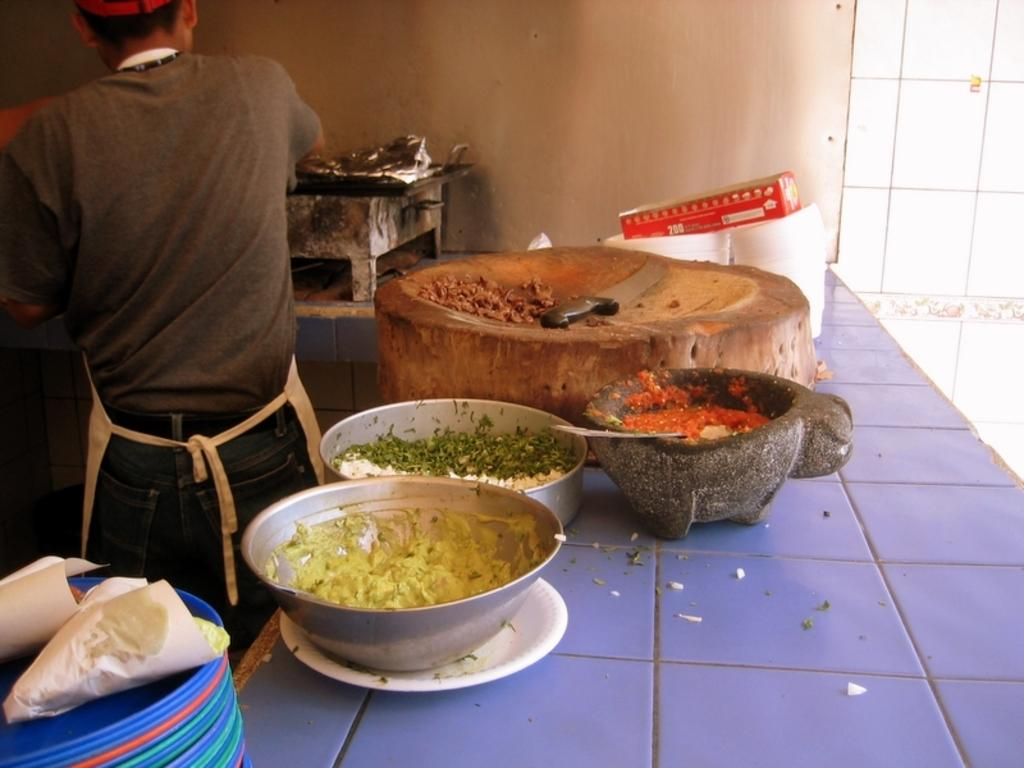What objects are present in the image that are typically used for serving or eating food? There are plates and bowls in the image that are used for serving or eating food. What utensil can be seen in the image? There is a knife in the image. Can you describe the person in the image? There is a person standing in the image. What type of container is present in the image? There is a cardboard box in the image. What appliance is visible in the image? There is a gas stove in the image. What architectural feature is present in the image? There is a wall in the image. What type of cup is being exchanged between the person and the wall in the image? There is no cup present in the image, nor is there any exchange between the person and the wall. How does the person express their feelings of hate towards the food items in the image? There is no indication of hate or any negative emotions towards the food items in the image. 